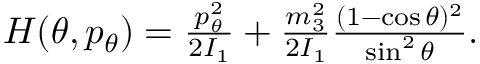<formula> <loc_0><loc_0><loc_500><loc_500>\begin{array} { r } { H ( \theta , p _ { \theta } ) = \frac { p _ { \theta } ^ { 2 } } { 2 I _ { 1 } } + \frac { m _ { 3 } ^ { 2 } } { 2 I _ { 1 } } \frac { ( 1 - \cos \theta ) ^ { 2 } } { \sin ^ { 2 } \theta } . } \end{array}</formula> 